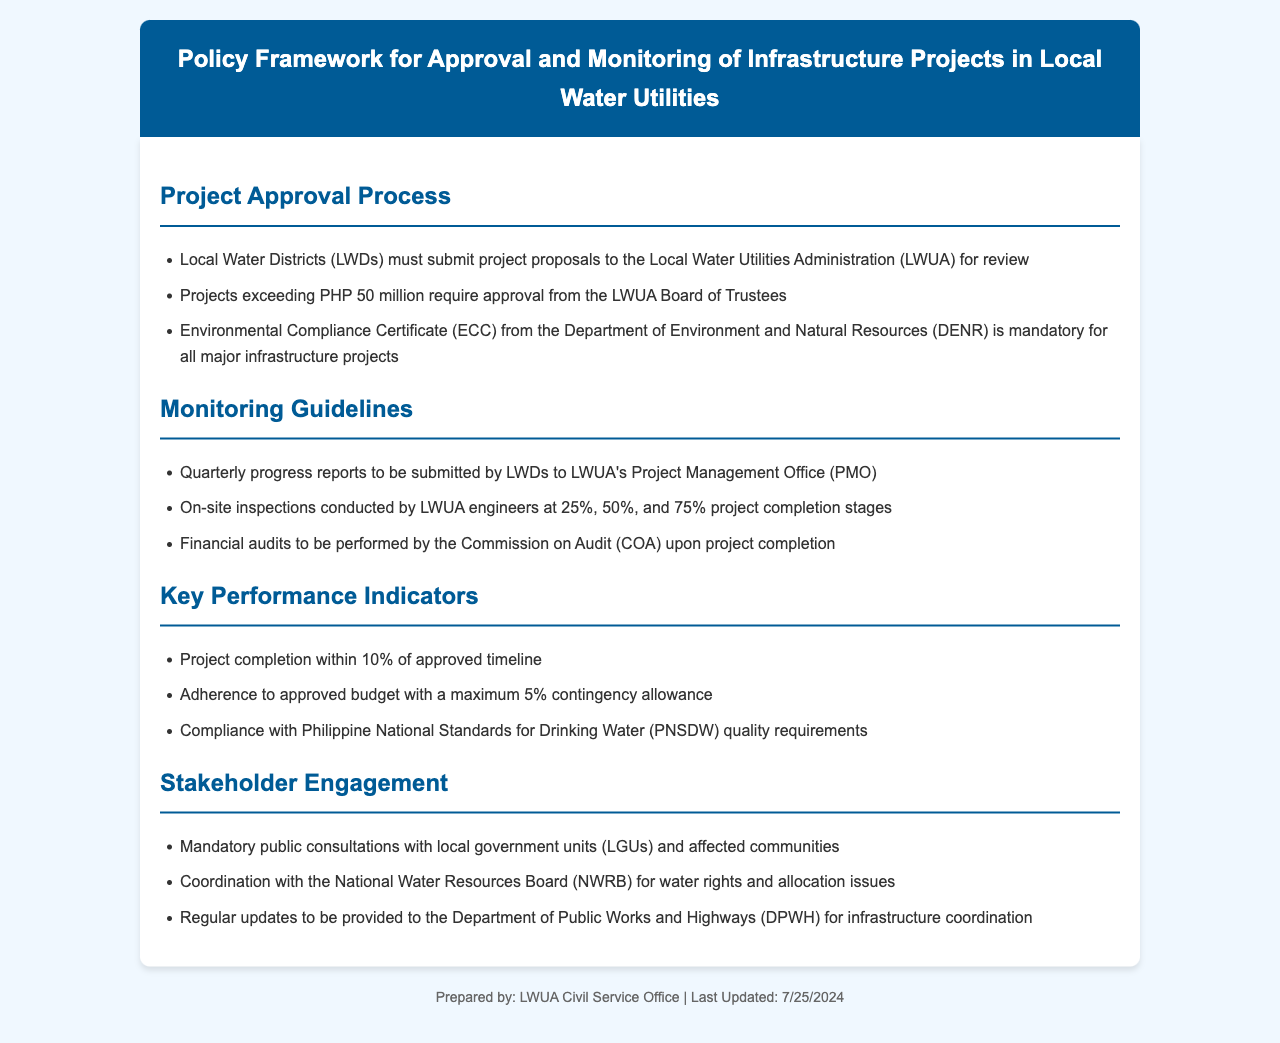what is the project approval threshold for the LWUA Board of Trustees? Projects exceeding PHP 50 million require approval from the LWUA Board of Trustees.
Answer: PHP 50 million what is the mandatory certificate for major infrastructure projects? An Environmental Compliance Certificate (ECC) from the Department of Environment and Natural Resources (DENR) is mandatory for all major infrastructure projects.
Answer: Environmental Compliance Certificate (ECC) how often must LWDs submit progress reports to the LWUA? Quarterly progress reports to be submitted by LWDs to LWUA's Project Management Office (PMO).
Answer: Quarterly how many stages of project completion are monitored on-site by LWUA engineers? On-site inspections conducted by LWUA engineers at 25%, 50%, and 75% project completion stages.
Answer: 3 stages what is the maximum contingency allowance for adherence to the approved budget? Adherence to approved budget with a maximum 5% contingency allowance.
Answer: 5% are public consultations required for local water utility projects? Mandatory public consultations with local government units (LGUs) and affected communities.
Answer: Yes which board coordinates water rights and allocation issues? Coordination with the National Water Resources Board (NWRB) for water rights and allocation issues.
Answer: National Water Resources Board (NWRB) what is the compliance requirement regarding drinking water quality? Compliance with Philippine National Standards for Drinking Water (PNSDW) quality requirements.
Answer: Philippine National Standards for Drinking Water (PNSDW) who performs financial audits upon project completion? Financial audits to be performed by the Commission on Audit (COA) upon project completion.
Answer: Commission on Audit (COA) 